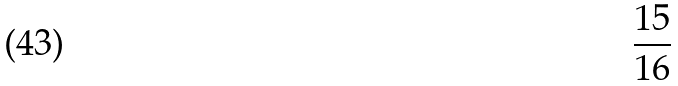Convert formula to latex. <formula><loc_0><loc_0><loc_500><loc_500>\frac { 1 5 } { 1 6 }</formula> 